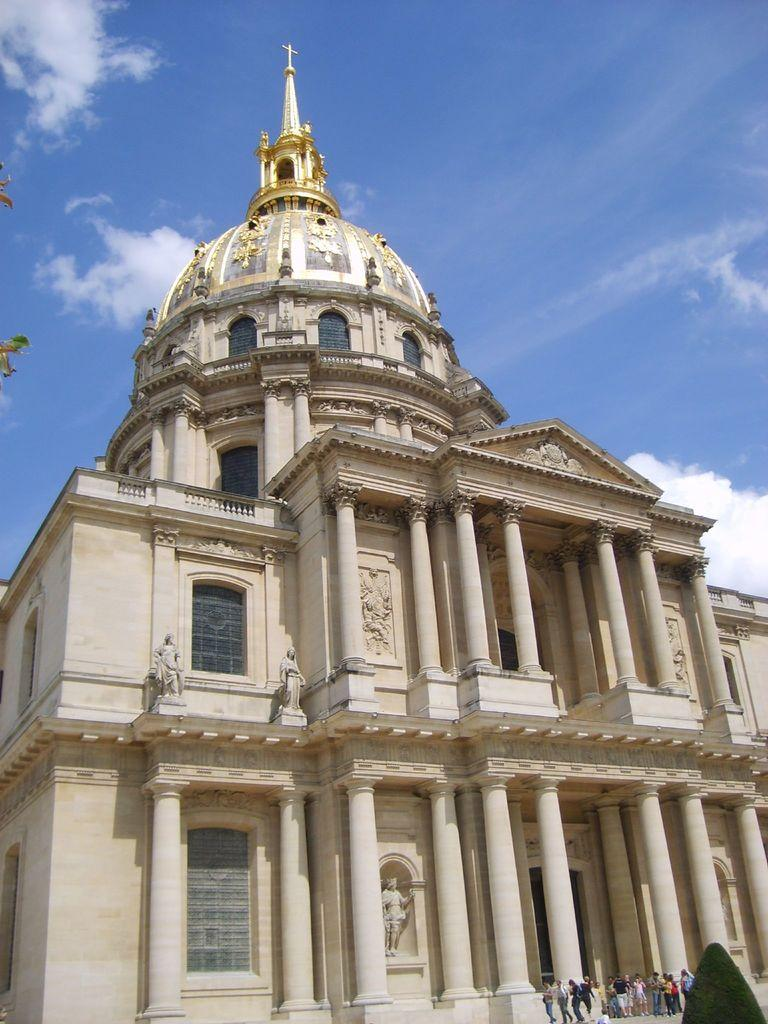How many people can be seen in the image? There are people in the image, but the exact number is not specified. What type of natural element is present in the image? There is a tree in the image. What type of structure is visible in the image? There is a building in the image. What type of decorative elements can be seen in the image? There are statues in the image. What architectural feature is present in the image? There are pillars in the image. What can be seen on the left side of the image? Leaves are visible on the left side of the image. What is visible in the background of the image? The sky is visible in the background of the image. What type of weather can be inferred from the image? Clouds are present in the sky, suggesting a partly cloudy day. What type of pan is being used to cook food in the image? There is no pan or cooking activity present in the image. What is the end result of the people's actions in the image? The image does not depict a specific action or end result; it simply shows people, a tree, a building, statues, pillars, leaves, and the sky with clouds. 